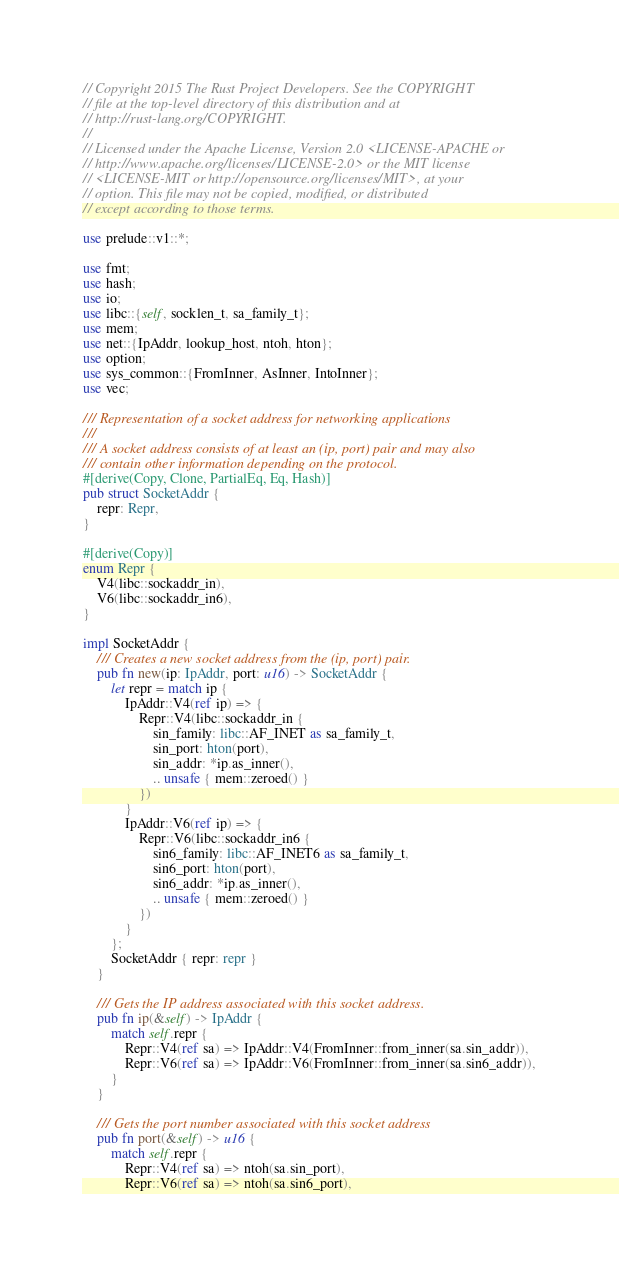<code> <loc_0><loc_0><loc_500><loc_500><_Rust_>// Copyright 2015 The Rust Project Developers. See the COPYRIGHT
// file at the top-level directory of this distribution and at
// http://rust-lang.org/COPYRIGHT.
//
// Licensed under the Apache License, Version 2.0 <LICENSE-APACHE or
// http://www.apache.org/licenses/LICENSE-2.0> or the MIT license
// <LICENSE-MIT or http://opensource.org/licenses/MIT>, at your
// option. This file may not be copied, modified, or distributed
// except according to those terms.

use prelude::v1::*;

use fmt;
use hash;
use io;
use libc::{self, socklen_t, sa_family_t};
use mem;
use net::{IpAddr, lookup_host, ntoh, hton};
use option;
use sys_common::{FromInner, AsInner, IntoInner};
use vec;

/// Representation of a socket address for networking applications
///
/// A socket address consists of at least an (ip, port) pair and may also
/// contain other information depending on the protocol.
#[derive(Copy, Clone, PartialEq, Eq, Hash)]
pub struct SocketAddr {
    repr: Repr,
}

#[derive(Copy)]
enum Repr {
    V4(libc::sockaddr_in),
    V6(libc::sockaddr_in6),
}

impl SocketAddr {
    /// Creates a new socket address from the (ip, port) pair.
    pub fn new(ip: IpAddr, port: u16) -> SocketAddr {
        let repr = match ip {
            IpAddr::V4(ref ip) => {
                Repr::V4(libc::sockaddr_in {
                    sin_family: libc::AF_INET as sa_family_t,
                    sin_port: hton(port),
                    sin_addr: *ip.as_inner(),
                    .. unsafe { mem::zeroed() }
                })
            }
            IpAddr::V6(ref ip) => {
                Repr::V6(libc::sockaddr_in6 {
                    sin6_family: libc::AF_INET6 as sa_family_t,
                    sin6_port: hton(port),
                    sin6_addr: *ip.as_inner(),
                    .. unsafe { mem::zeroed() }
                })
            }
        };
        SocketAddr { repr: repr }
    }

    /// Gets the IP address associated with this socket address.
    pub fn ip(&self) -> IpAddr {
        match self.repr {
            Repr::V4(ref sa) => IpAddr::V4(FromInner::from_inner(sa.sin_addr)),
            Repr::V6(ref sa) => IpAddr::V6(FromInner::from_inner(sa.sin6_addr)),
        }
    }

    /// Gets the port number associated with this socket address
    pub fn port(&self) -> u16 {
        match self.repr {
            Repr::V4(ref sa) => ntoh(sa.sin_port),
            Repr::V6(ref sa) => ntoh(sa.sin6_port),</code> 